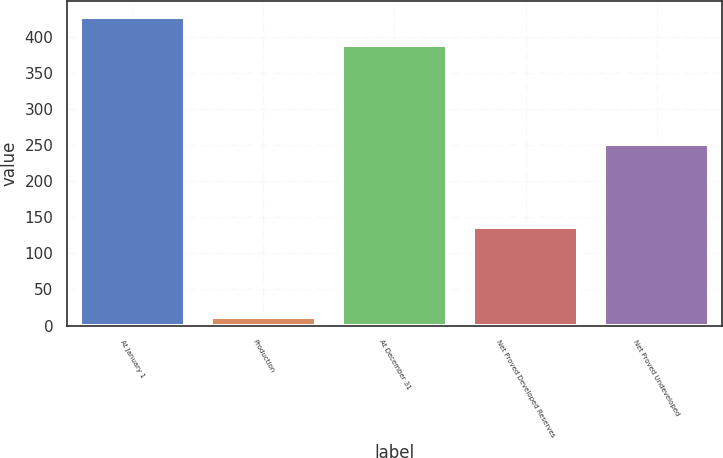Convert chart. <chart><loc_0><loc_0><loc_500><loc_500><bar_chart><fcel>At January 1<fcel>Production<fcel>At December 31<fcel>Net Proved Developed Reserves<fcel>Net Proved Undeveloped<nl><fcel>427.2<fcel>12<fcel>388<fcel>137<fcel>251<nl></chart> 